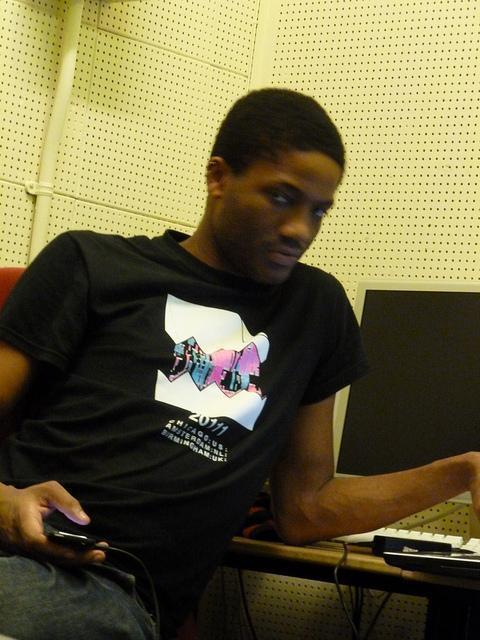What is the purpose of the holes behind him?
Pick the correct solution from the four options below to address the question.
Options: Ventilation, seeing outside, decoration, hanging things. Hanging things. 